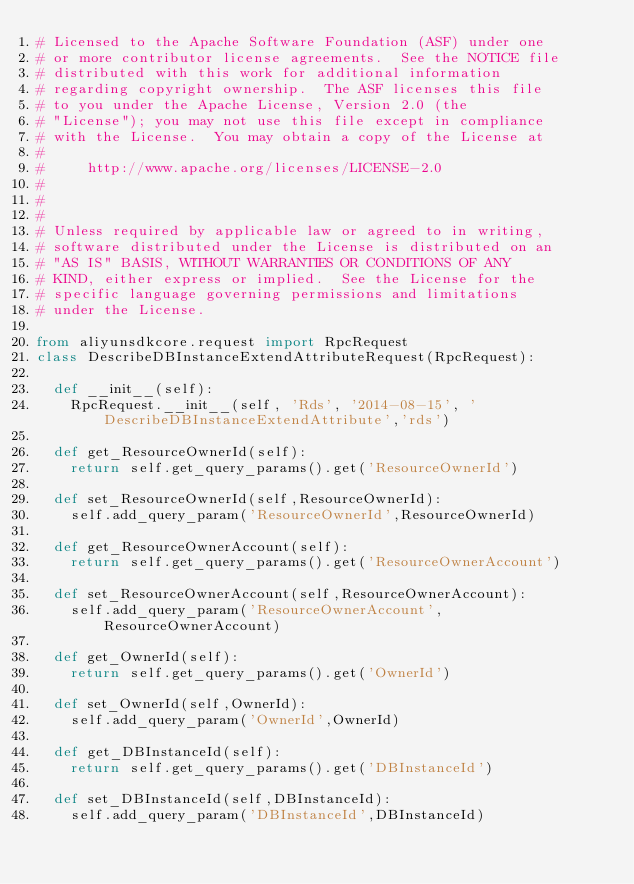<code> <loc_0><loc_0><loc_500><loc_500><_Python_># Licensed to the Apache Software Foundation (ASF) under one
# or more contributor license agreements.  See the NOTICE file
# distributed with this work for additional information
# regarding copyright ownership.  The ASF licenses this file
# to you under the Apache License, Version 2.0 (the
# "License"); you may not use this file except in compliance
# with the License.  You may obtain a copy of the License at
#
#     http://www.apache.org/licenses/LICENSE-2.0
#
#
#
# Unless required by applicable law or agreed to in writing,
# software distributed under the License is distributed on an
# "AS IS" BASIS, WITHOUT WARRANTIES OR CONDITIONS OF ANY
# KIND, either express or implied.  See the License for the
# specific language governing permissions and limitations
# under the License.

from aliyunsdkcore.request import RpcRequest
class DescribeDBInstanceExtendAttributeRequest(RpcRequest):

	def __init__(self):
		RpcRequest.__init__(self, 'Rds', '2014-08-15', 'DescribeDBInstanceExtendAttribute','rds')

	def get_ResourceOwnerId(self):
		return self.get_query_params().get('ResourceOwnerId')

	def set_ResourceOwnerId(self,ResourceOwnerId):
		self.add_query_param('ResourceOwnerId',ResourceOwnerId)

	def get_ResourceOwnerAccount(self):
		return self.get_query_params().get('ResourceOwnerAccount')

	def set_ResourceOwnerAccount(self,ResourceOwnerAccount):
		self.add_query_param('ResourceOwnerAccount',ResourceOwnerAccount)

	def get_OwnerId(self):
		return self.get_query_params().get('OwnerId')

	def set_OwnerId(self,OwnerId):
		self.add_query_param('OwnerId',OwnerId)

	def get_DBInstanceId(self):
		return self.get_query_params().get('DBInstanceId')

	def set_DBInstanceId(self,DBInstanceId):
		self.add_query_param('DBInstanceId',DBInstanceId)</code> 